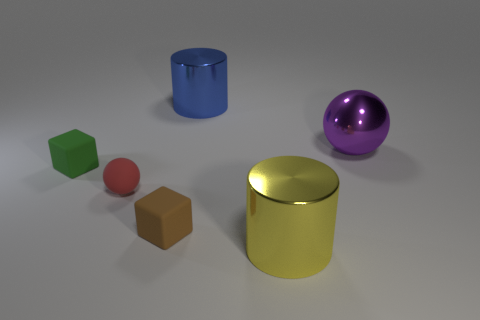How many other yellow things are the same shape as the yellow metal thing?
Your answer should be very brief. 0. There is a thing that is both on the right side of the red sphere and to the left of the blue shiny object; what is it made of?
Your answer should be very brief. Rubber. Does the big blue thing have the same material as the red thing?
Make the answer very short. No. How many large red matte cubes are there?
Your answer should be very brief. 0. What is the color of the object in front of the block in front of the matte thing that is left of the red rubber object?
Your answer should be compact. Yellow. Does the rubber sphere have the same color as the shiny ball?
Ensure brevity in your answer.  No. What number of tiny objects are both in front of the green matte thing and behind the brown object?
Your answer should be very brief. 1. How many shiny objects are either big yellow objects or red things?
Make the answer very short. 1. There is a sphere left of the big yellow metal cylinder that is on the right side of the red ball; what is its material?
Offer a terse response. Rubber. What shape is the brown object that is the same size as the green object?
Offer a very short reply. Cube. 